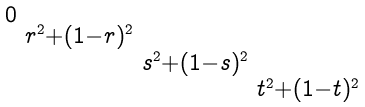Convert formula to latex. <formula><loc_0><loc_0><loc_500><loc_500>\begin{smallmatrix} 0 & & & \\ & r ^ { 2 } + ( 1 - r ) ^ { 2 } & & \\ & & s ^ { 2 } + ( 1 - s ) ^ { 2 } & \\ & & & t ^ { 2 } + ( 1 - t ) ^ { 2 } \end{smallmatrix}</formula> 